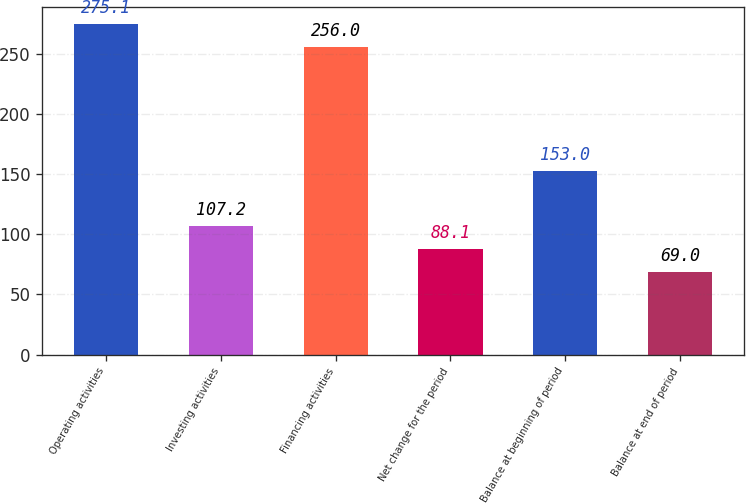<chart> <loc_0><loc_0><loc_500><loc_500><bar_chart><fcel>Operating activities<fcel>Investing activities<fcel>Financing activities<fcel>Net change for the period<fcel>Balance at beginning of period<fcel>Balance at end of period<nl><fcel>275.1<fcel>107.2<fcel>256<fcel>88.1<fcel>153<fcel>69<nl></chart> 